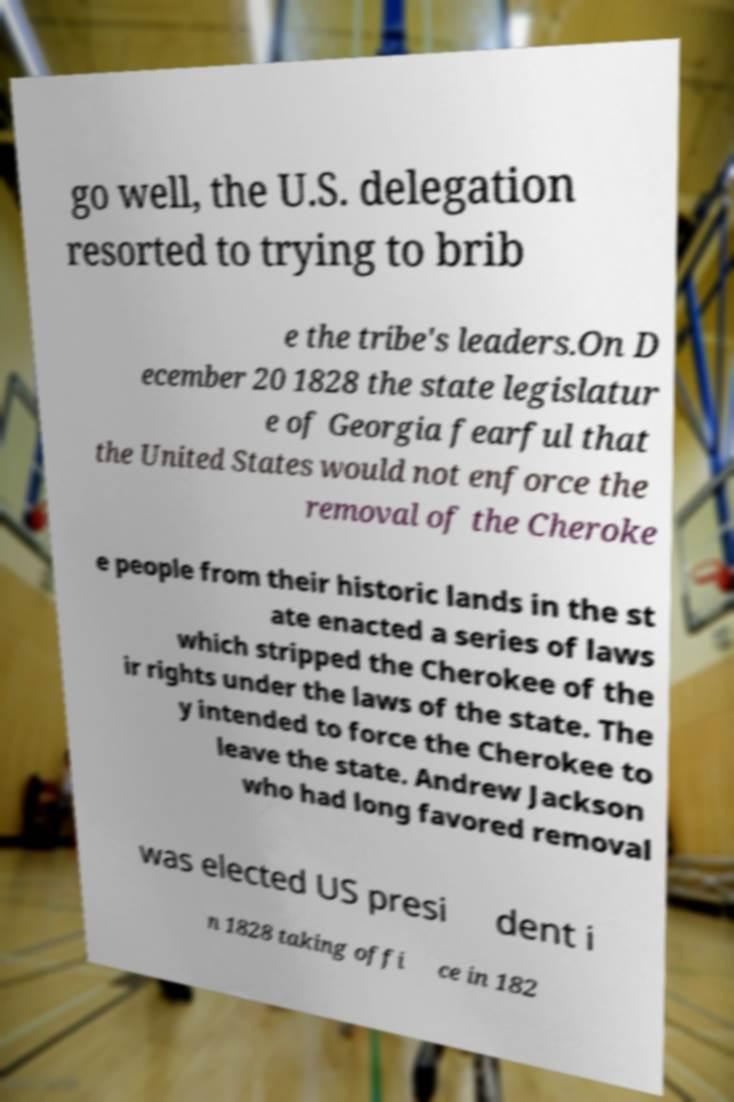There's text embedded in this image that I need extracted. Can you transcribe it verbatim? go well, the U.S. delegation resorted to trying to brib e the tribe's leaders.On D ecember 20 1828 the state legislatur e of Georgia fearful that the United States would not enforce the removal of the Cheroke e people from their historic lands in the st ate enacted a series of laws which stripped the Cherokee of the ir rights under the laws of the state. The y intended to force the Cherokee to leave the state. Andrew Jackson who had long favored removal was elected US presi dent i n 1828 taking offi ce in 182 